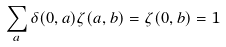Convert formula to latex. <formula><loc_0><loc_0><loc_500><loc_500>\sum _ { a } \delta ( 0 , a ) \zeta ( a , b ) = \zeta ( 0 , b ) = 1</formula> 